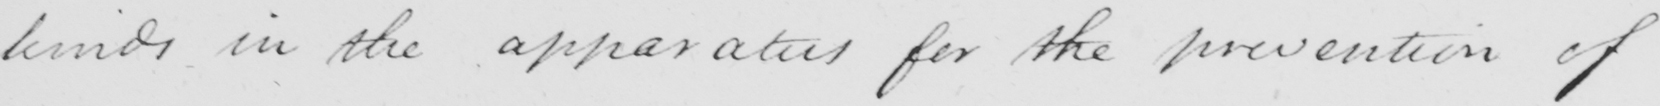What is written in this line of handwriting? kinds in the apparatus for the prevention of 